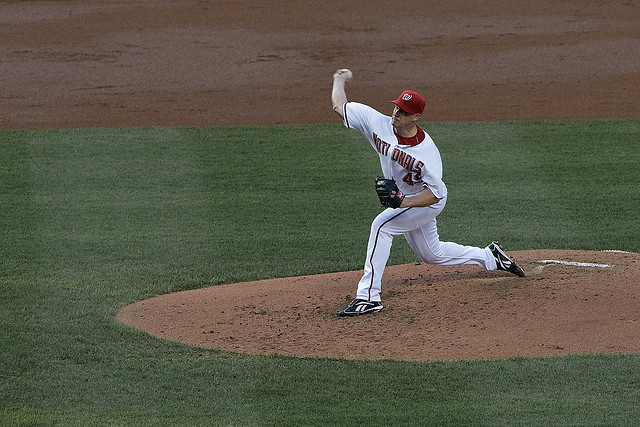Please identify all text content in this image. ONALS 4 